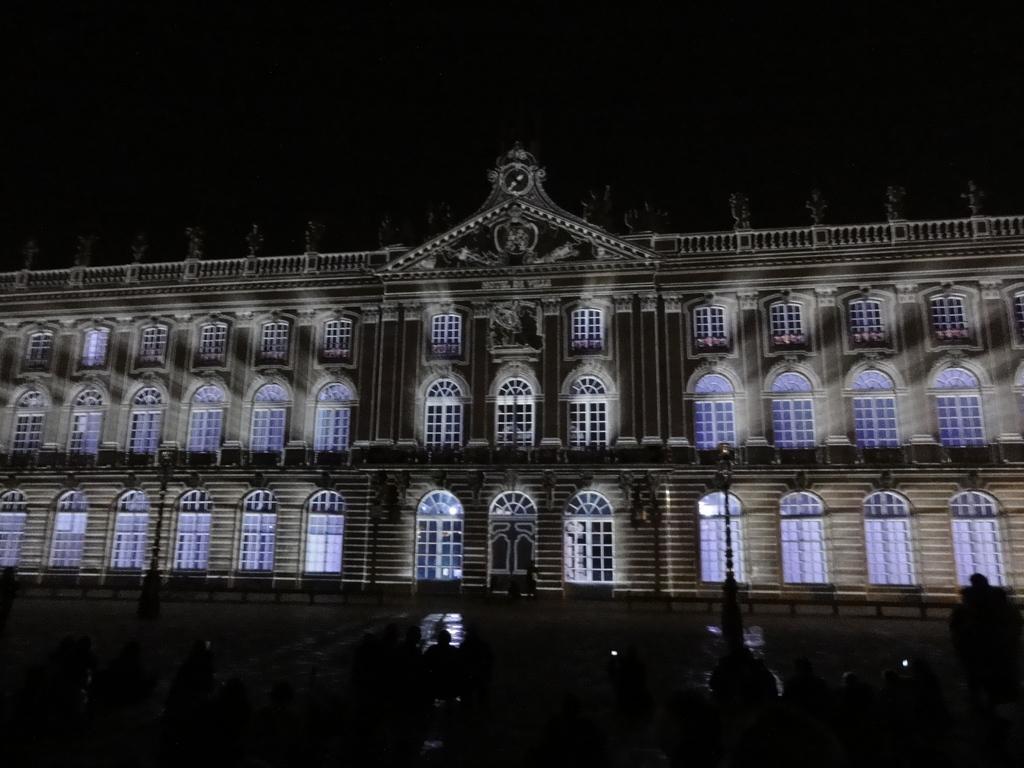Describe this image in one or two sentences. In this picture we can see a building her,e we can also see windows of the building, there is a pole here. 